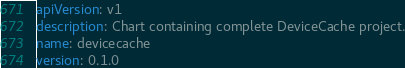<code> <loc_0><loc_0><loc_500><loc_500><_YAML_>apiVersion: v1
description: Chart containing complete DeviceCache project.
name: devicecache
version: 0.1.0</code> 